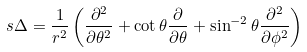Convert formula to latex. <formula><loc_0><loc_0><loc_500><loc_500>\ s { \Delta } = \frac { 1 } { r ^ { 2 } } \left ( \frac { \partial ^ { 2 } } { \partial \theta ^ { 2 } } + \cot \theta \frac { \partial } { \partial \theta } + \sin ^ { - 2 } \theta \frac { \partial ^ { 2 } } { \partial \phi ^ { 2 } } \right )</formula> 